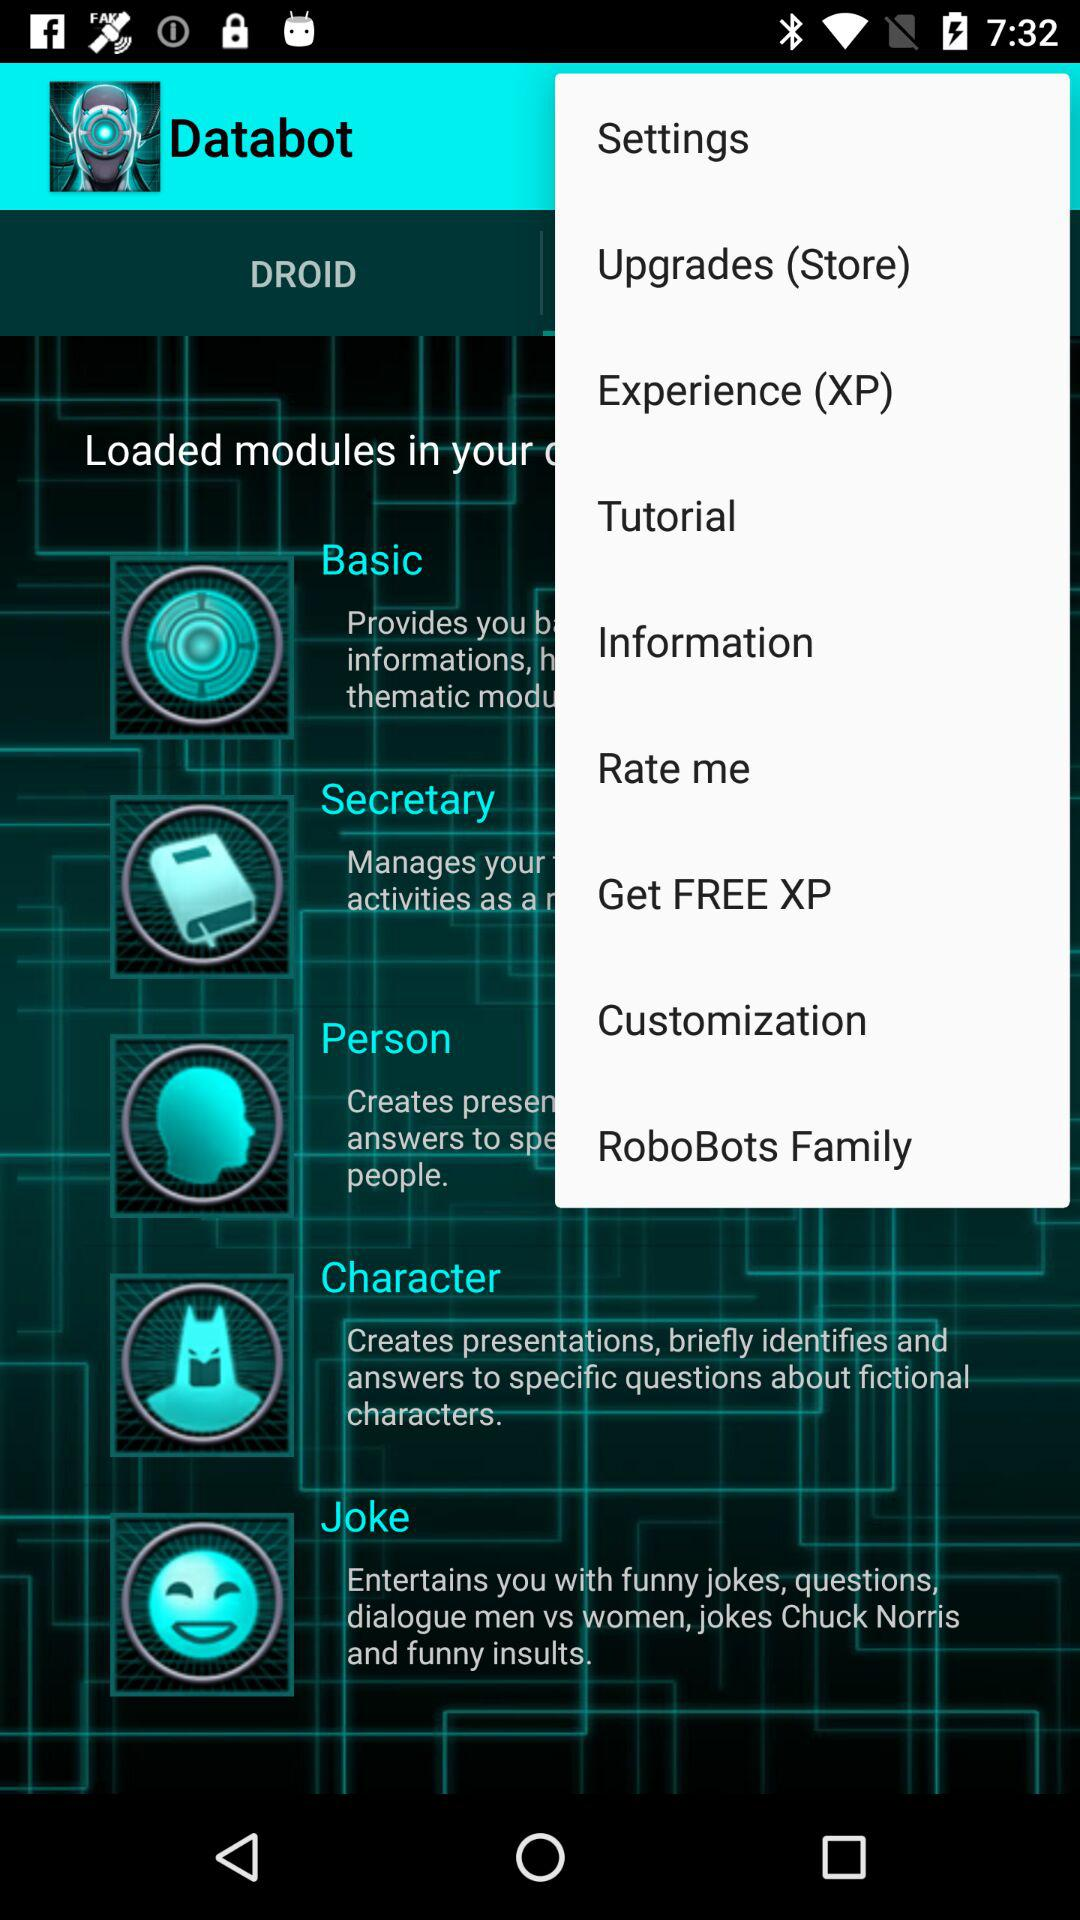What is the application name? The application name is "Databot". 